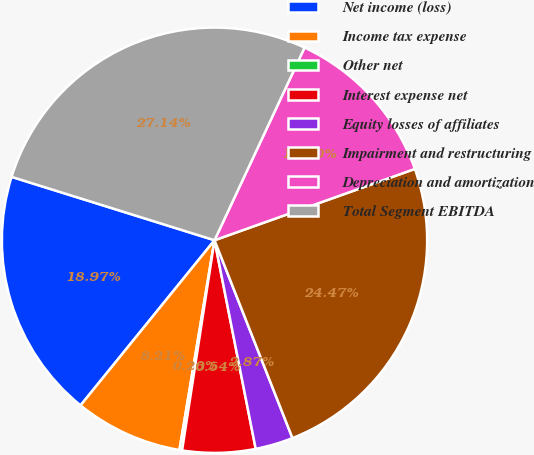<chart> <loc_0><loc_0><loc_500><loc_500><pie_chart><fcel>Net income (loss)<fcel>Income tax expense<fcel>Other net<fcel>Interest expense net<fcel>Equity losses of affiliates<fcel>Impairment and restructuring<fcel>Depreciation and amortization<fcel>Total Segment EBITDA<nl><fcel>18.97%<fcel>8.21%<fcel>0.2%<fcel>5.54%<fcel>2.87%<fcel>24.47%<fcel>12.6%<fcel>27.14%<nl></chart> 